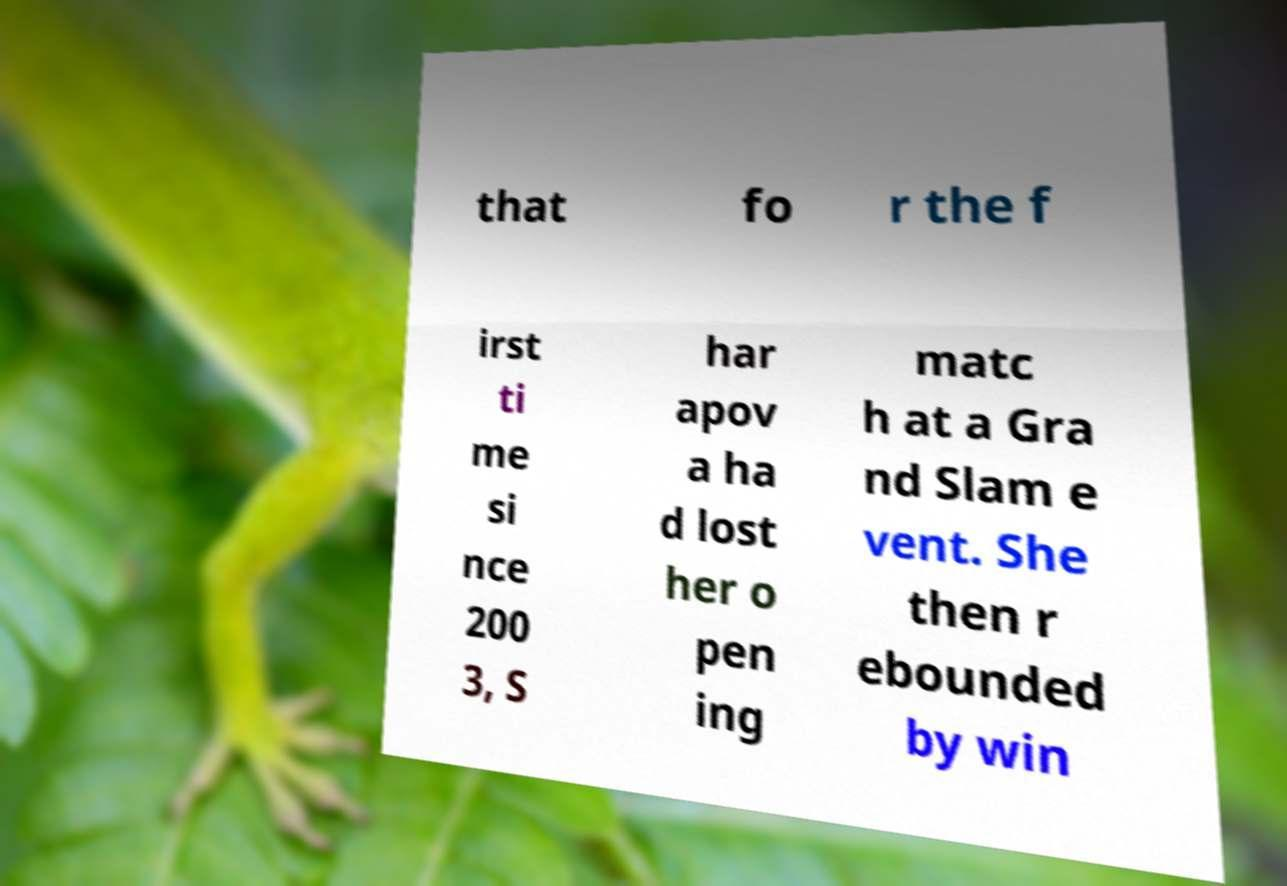There's text embedded in this image that I need extracted. Can you transcribe it verbatim? that fo r the f irst ti me si nce 200 3, S har apov a ha d lost her o pen ing matc h at a Gra nd Slam e vent. She then r ebounded by win 